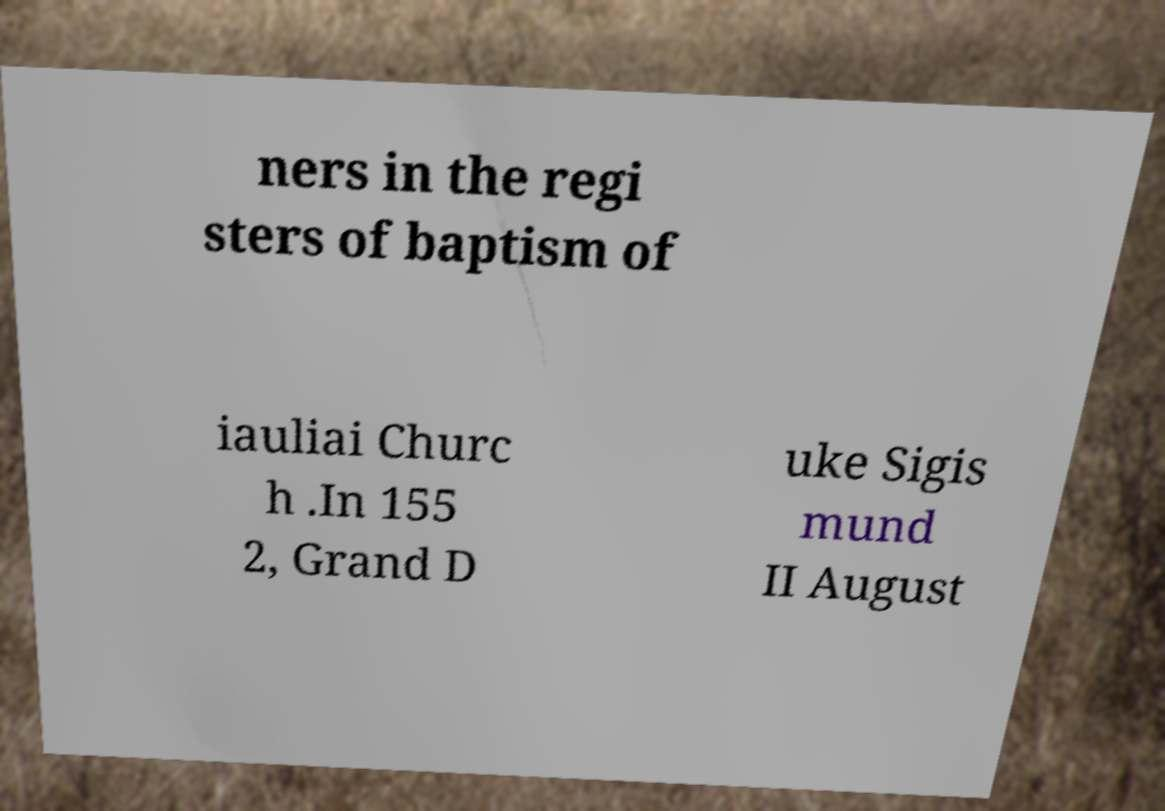For documentation purposes, I need the text within this image transcribed. Could you provide that? ners in the regi sters of baptism of iauliai Churc h .In 155 2, Grand D uke Sigis mund II August 